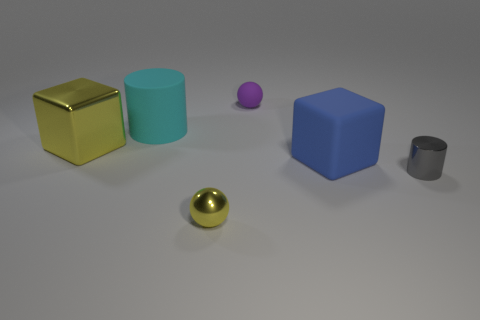Add 2 small gray shiny things. How many objects exist? 8 Subtract all balls. How many objects are left? 4 Add 2 metallic cubes. How many metallic cubes are left? 3 Add 2 big purple metal objects. How many big purple metal objects exist? 2 Subtract 0 cyan balls. How many objects are left? 6 Subtract all big blue blocks. Subtract all blue matte objects. How many objects are left? 4 